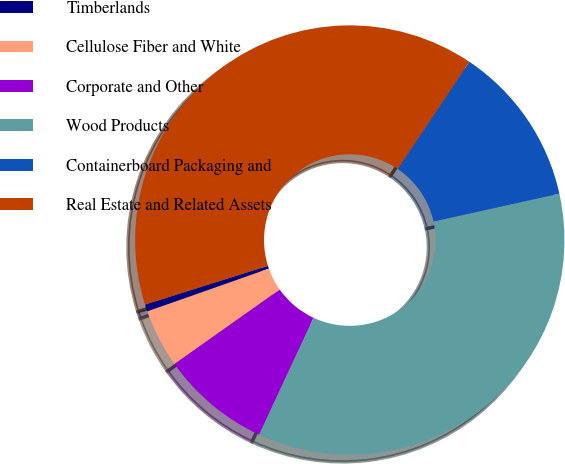<chart> <loc_0><loc_0><loc_500><loc_500><pie_chart><fcel>Timberlands<fcel>Cellulose Fiber and White<fcel>Corporate and Other<fcel>Wood Products<fcel>Containerboard Packaging and<fcel>Real Estate and Related Assets<nl><fcel>0.54%<fcel>4.4%<fcel>8.27%<fcel>35.4%<fcel>12.13%<fcel>39.26%<nl></chart> 